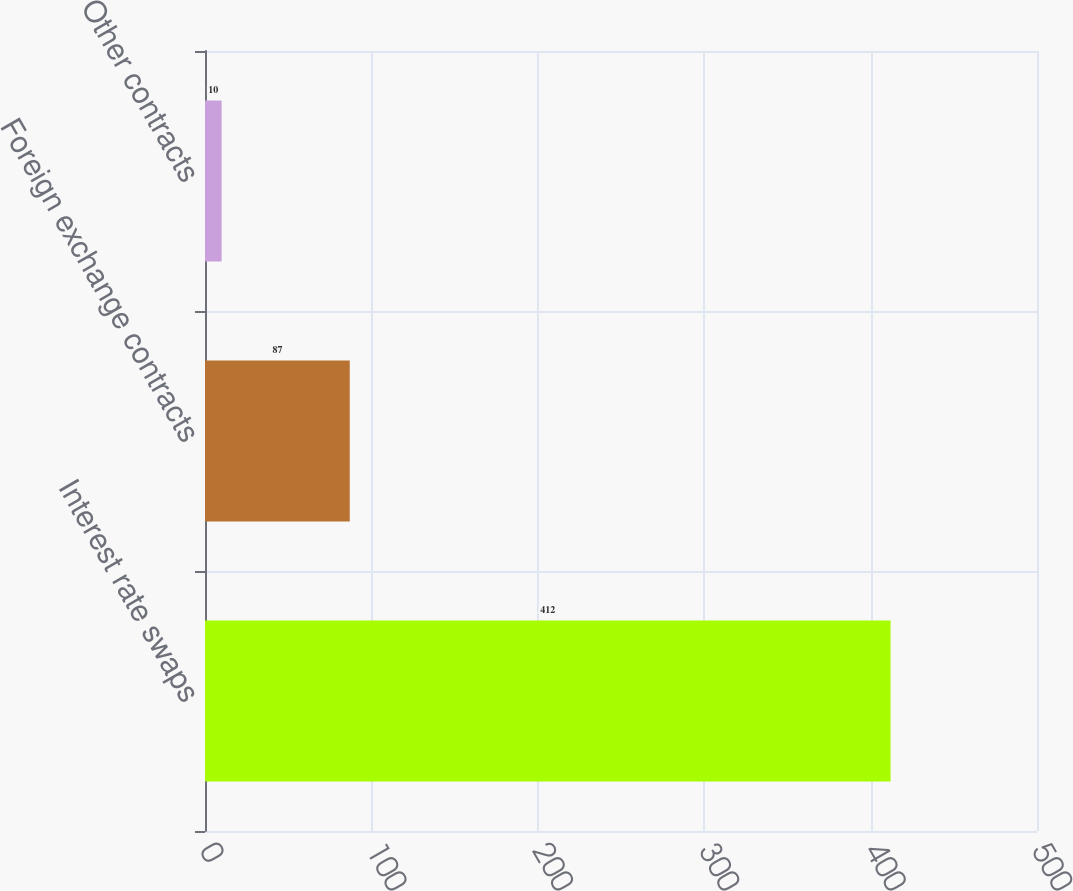<chart> <loc_0><loc_0><loc_500><loc_500><bar_chart><fcel>Interest rate swaps<fcel>Foreign exchange contracts<fcel>Other contracts<nl><fcel>412<fcel>87<fcel>10<nl></chart> 